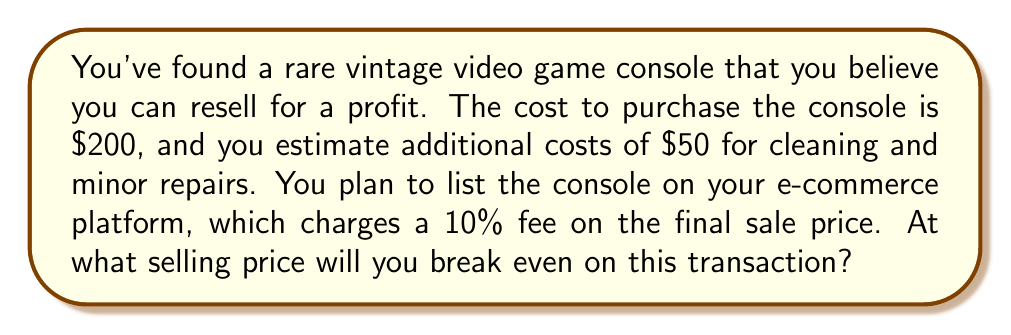Give your solution to this math problem. Let's approach this step-by-step:

1) Let $x$ be the selling price of the console.

2) Calculate the total costs:
   - Purchase cost: $200
   - Cleaning and repairs: $50
   - Platform fee: 10% of selling price = $0.1x$
   Total costs = $200 + 50 + 0.1x = 250 + 0.1x$

3) At the break-even point, the revenue equals the total costs:
   $x = 250 + 0.1x$

4) Solve the equation:
   $x - 0.1x = 250$
   $0.9x = 250$

5) Divide both sides by 0.9:
   $x = \frac{250}{0.9} = \frac{2500}{9} \approx 277.78$

Therefore, the break-even selling price is $\frac{2500}{9}$ or approximately $277.78.

To verify:
Revenue: $\frac{2500}{9}$
Costs: $250 + 0.1(\frac{2500}{9}) = 250 + \frac{250}{9} = \frac{2500}{9}$

Revenue equals costs, confirming the break-even point.
Answer: $\frac{2500}{9}$ 